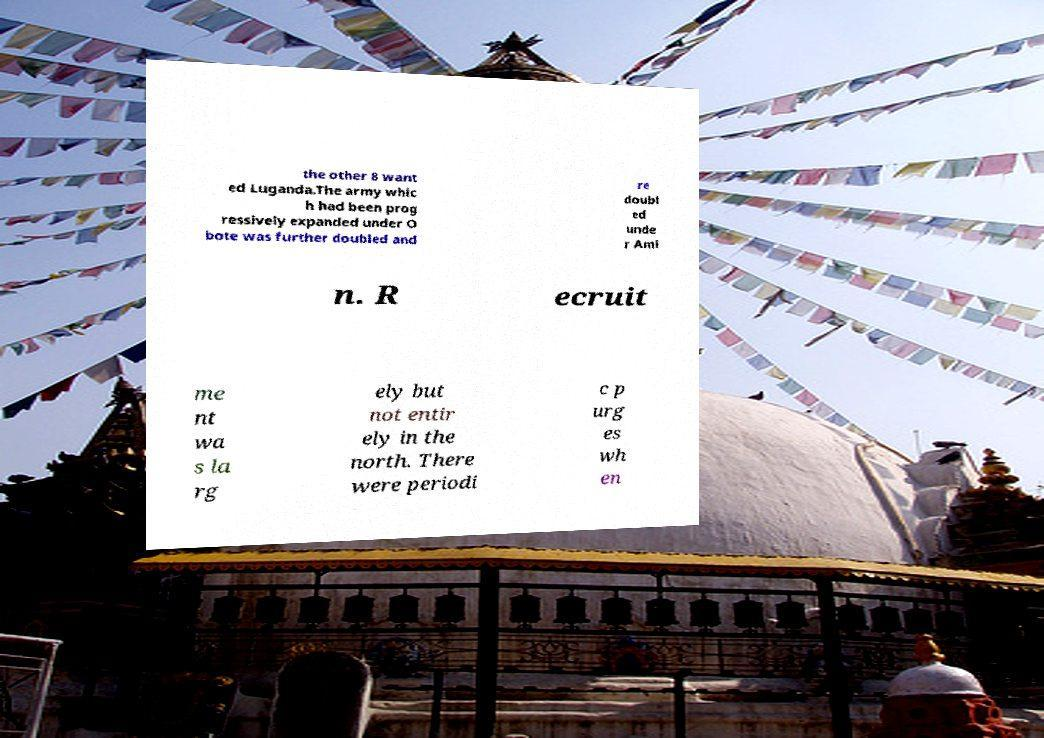There's text embedded in this image that I need extracted. Can you transcribe it verbatim? the other 8 want ed Luganda.The army whic h had been prog ressively expanded under O bote was further doubled and re doubl ed unde r Ami n. R ecruit me nt wa s la rg ely but not entir ely in the north. There were periodi c p urg es wh en 